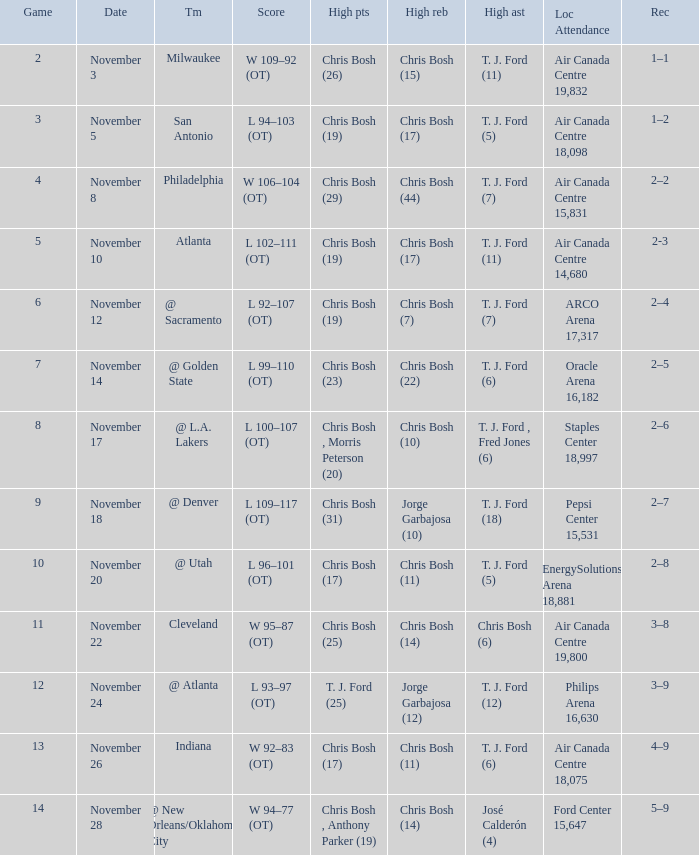Could you parse the entire table? {'header': ['Game', 'Date', 'Tm', 'Score', 'High pts', 'High reb', 'High ast', 'Loc Attendance', 'Rec'], 'rows': [['2', 'November 3', 'Milwaukee', 'W 109–92 (OT)', 'Chris Bosh (26)', 'Chris Bosh (15)', 'T. J. Ford (11)', 'Air Canada Centre 19,832', '1–1'], ['3', 'November 5', 'San Antonio', 'L 94–103 (OT)', 'Chris Bosh (19)', 'Chris Bosh (17)', 'T. J. Ford (5)', 'Air Canada Centre 18,098', '1–2'], ['4', 'November 8', 'Philadelphia', 'W 106–104 (OT)', 'Chris Bosh (29)', 'Chris Bosh (44)', 'T. J. Ford (7)', 'Air Canada Centre 15,831', '2–2'], ['5', 'November 10', 'Atlanta', 'L 102–111 (OT)', 'Chris Bosh (19)', 'Chris Bosh (17)', 'T. J. Ford (11)', 'Air Canada Centre 14,680', '2-3'], ['6', 'November 12', '@ Sacramento', 'L 92–107 (OT)', 'Chris Bosh (19)', 'Chris Bosh (7)', 'T. J. Ford (7)', 'ARCO Arena 17,317', '2–4'], ['7', 'November 14', '@ Golden State', 'L 99–110 (OT)', 'Chris Bosh (23)', 'Chris Bosh (22)', 'T. J. Ford (6)', 'Oracle Arena 16,182', '2–5'], ['8', 'November 17', '@ L.A. Lakers', 'L 100–107 (OT)', 'Chris Bosh , Morris Peterson (20)', 'Chris Bosh (10)', 'T. J. Ford , Fred Jones (6)', 'Staples Center 18,997', '2–6'], ['9', 'November 18', '@ Denver', 'L 109–117 (OT)', 'Chris Bosh (31)', 'Jorge Garbajosa (10)', 'T. J. Ford (18)', 'Pepsi Center 15,531', '2–7'], ['10', 'November 20', '@ Utah', 'L 96–101 (OT)', 'Chris Bosh (17)', 'Chris Bosh (11)', 'T. J. Ford (5)', 'EnergySolutions Arena 18,881', '2–8'], ['11', 'November 22', 'Cleveland', 'W 95–87 (OT)', 'Chris Bosh (25)', 'Chris Bosh (14)', 'Chris Bosh (6)', 'Air Canada Centre 19,800', '3–8'], ['12', 'November 24', '@ Atlanta', 'L 93–97 (OT)', 'T. J. Ford (25)', 'Jorge Garbajosa (12)', 'T. J. Ford (12)', 'Philips Arena 16,630', '3–9'], ['13', 'November 26', 'Indiana', 'W 92–83 (OT)', 'Chris Bosh (17)', 'Chris Bosh (11)', 'T. J. Ford (6)', 'Air Canada Centre 18,075', '4–9'], ['14', 'November 28', '@ New Orleans/Oklahoma City', 'W 94–77 (OT)', 'Chris Bosh , Anthony Parker (19)', 'Chris Bosh (14)', 'José Calderón (4)', 'Ford Center 15,647', '5–9']]} Where was the game on November 20? EnergySolutions Arena 18,881. 